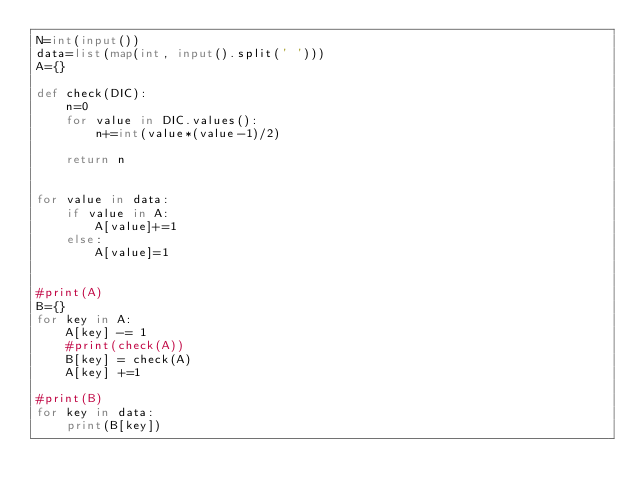<code> <loc_0><loc_0><loc_500><loc_500><_Python_>N=int(input())
data=list(map(int, input().split(' ')))
A={}

def check(DIC):
    n=0
    for value in DIC.values():
        n+=int(value*(value-1)/2)
    
    return n


for value in data:
    if value in A:
        A[value]+=1
    else:
        A[value]=1


#print(A)
B={}
for key in A:
    A[key] -= 1
    #print(check(A))
    B[key] = check(A)
    A[key] +=1

#print(B)
for key in data:
    print(B[key])</code> 